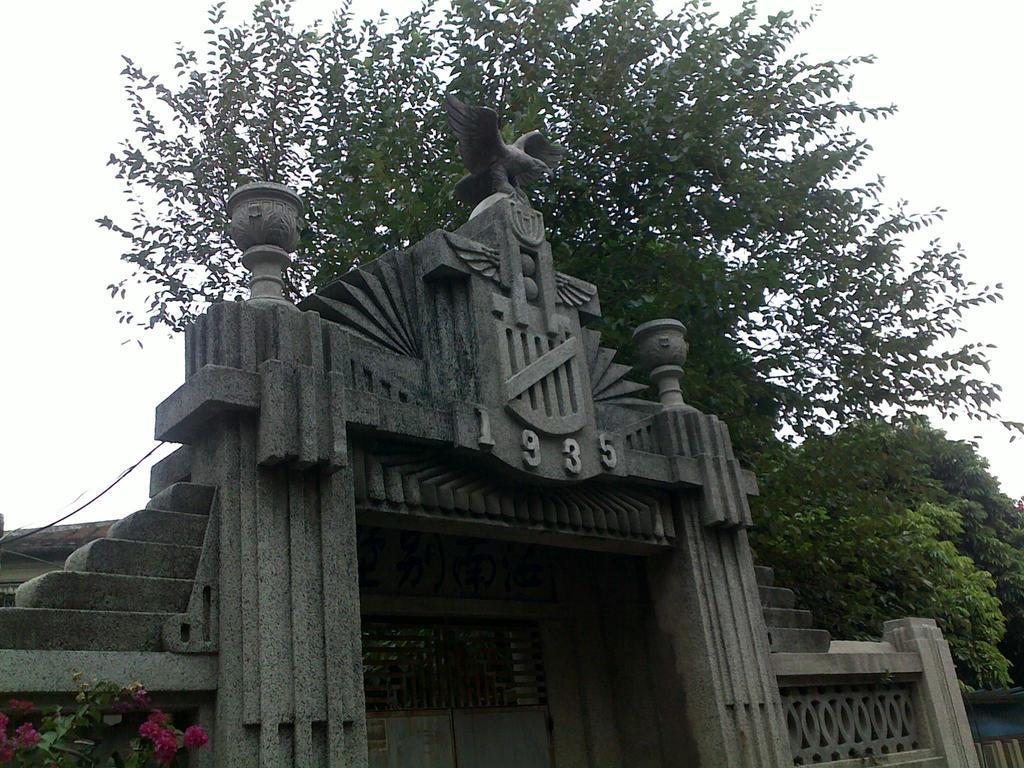How would you summarize this image in a sentence or two? In this picture, there is a stone structure with a gate. On the top of the structure, there is a statue with some text engraved on it. In the background, there is a tree. Towards the right, there is another tree. At the bottom, there is a plant with flowers. 